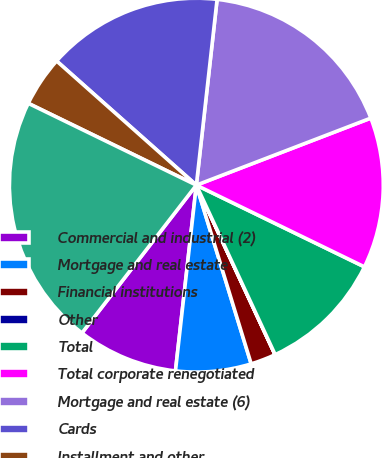<chart> <loc_0><loc_0><loc_500><loc_500><pie_chart><fcel>Commercial and industrial (2)<fcel>Mortgage and real estate<fcel>Financial institutions<fcel>Other<fcel>Total<fcel>Total corporate renegotiated<fcel>Mortgage and real estate (6)<fcel>Cards<fcel>Installment and other<fcel>Total consumer renegotiated<nl><fcel>8.7%<fcel>6.52%<fcel>2.18%<fcel>0.01%<fcel>10.87%<fcel>13.04%<fcel>17.39%<fcel>15.21%<fcel>4.35%<fcel>21.73%<nl></chart> 